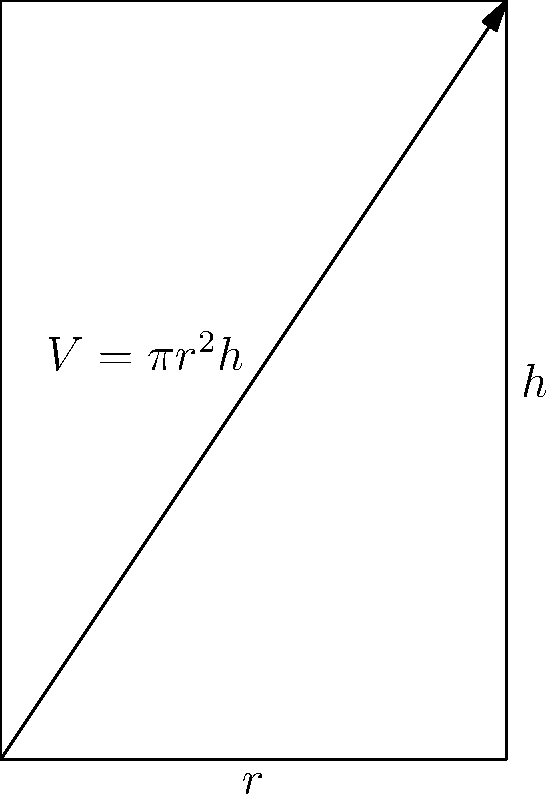As a city council member, you're planning a circular community center to accommodate diverse groups, including those attending the imam's interfaith events. The center's volume is given by $V = \pi r^2 h$, where $r$ is the radius and $h$ is the height. If the total surface area (including top, bottom, and sides) is constrained to 1000 square meters, what dimensions (radius and height) will maximize the center's capacity? Let's approach this step-by-step:

1) The surface area constraint gives us:
   $$ 2\pi r^2 + 2\pi rh = 1000 $$

2) Solve for $h$:
   $$ h = \frac{500}{\pi r} - r $$

3) Substitute this into the volume function:
   $$ V = \pi r^2 (\frac{500}{\pi r} - r) = 500r - \pi r^3 $$

4) To find the maximum, differentiate $V$ with respect to $r$ and set to zero:
   $$ \frac{dV}{dr} = 500 - 3\pi r^2 = 0 $$

5) Solve for $r$:
   $$ r = \sqrt{\frac{500}{3\pi}} \approx 7.26 \text{ meters} $$

6) Calculate $h$ using the result from step 2:
   $$ h = \frac{500}{\pi (7.26)} - 7.26 \approx 14.52 \text{ meters} $$

7) Verify this is a maximum by checking the second derivative is negative at this point.

These dimensions will maximize the capacity of the community center, allowing for optimal space for various community events.
Answer: $r \approx 7.26$ m, $h \approx 14.52$ m 